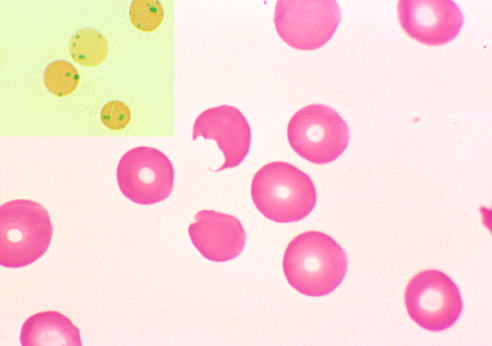what do the splenic macrophages pluck out?
Answer the question using a single word or phrase. Red cells with precipitates of denatured globin 